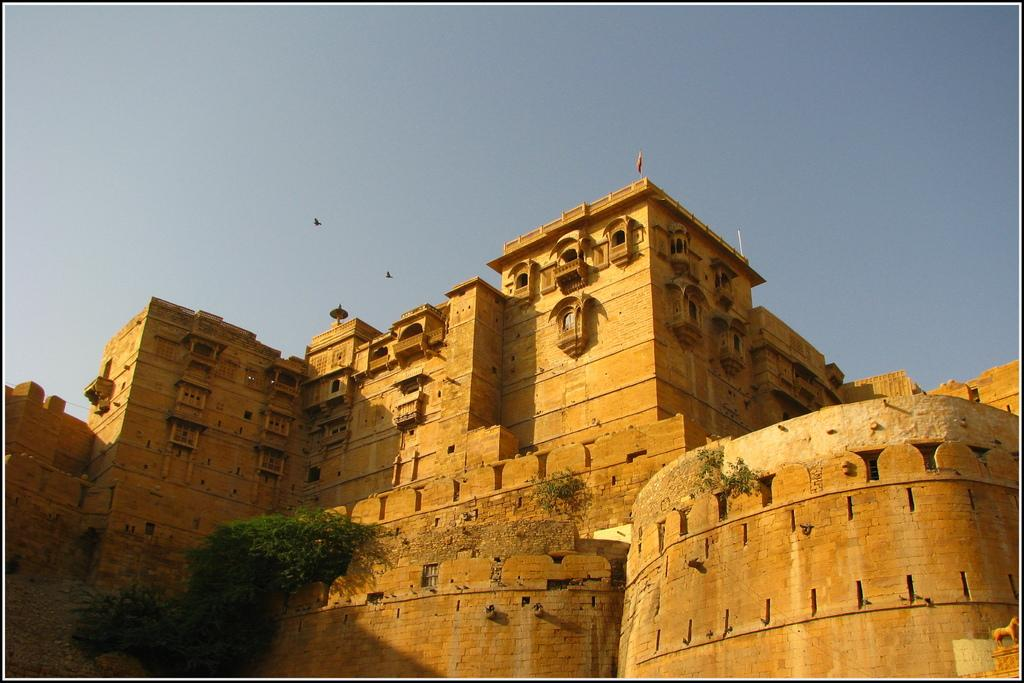What type of structure is in the image? There is a fort in the image. What can be seen in the bottom left corner of the image? There are plants in the bottom left of the image. What is visible at the top of the image? The sky is visible at the top of the image. What type of wood is used to build the fort in the image? There is no information about the type of wood used to build the fort in the image. What color is the chalk used to draw on the fort in the image? There is no chalk or drawing on the fort in the image. 